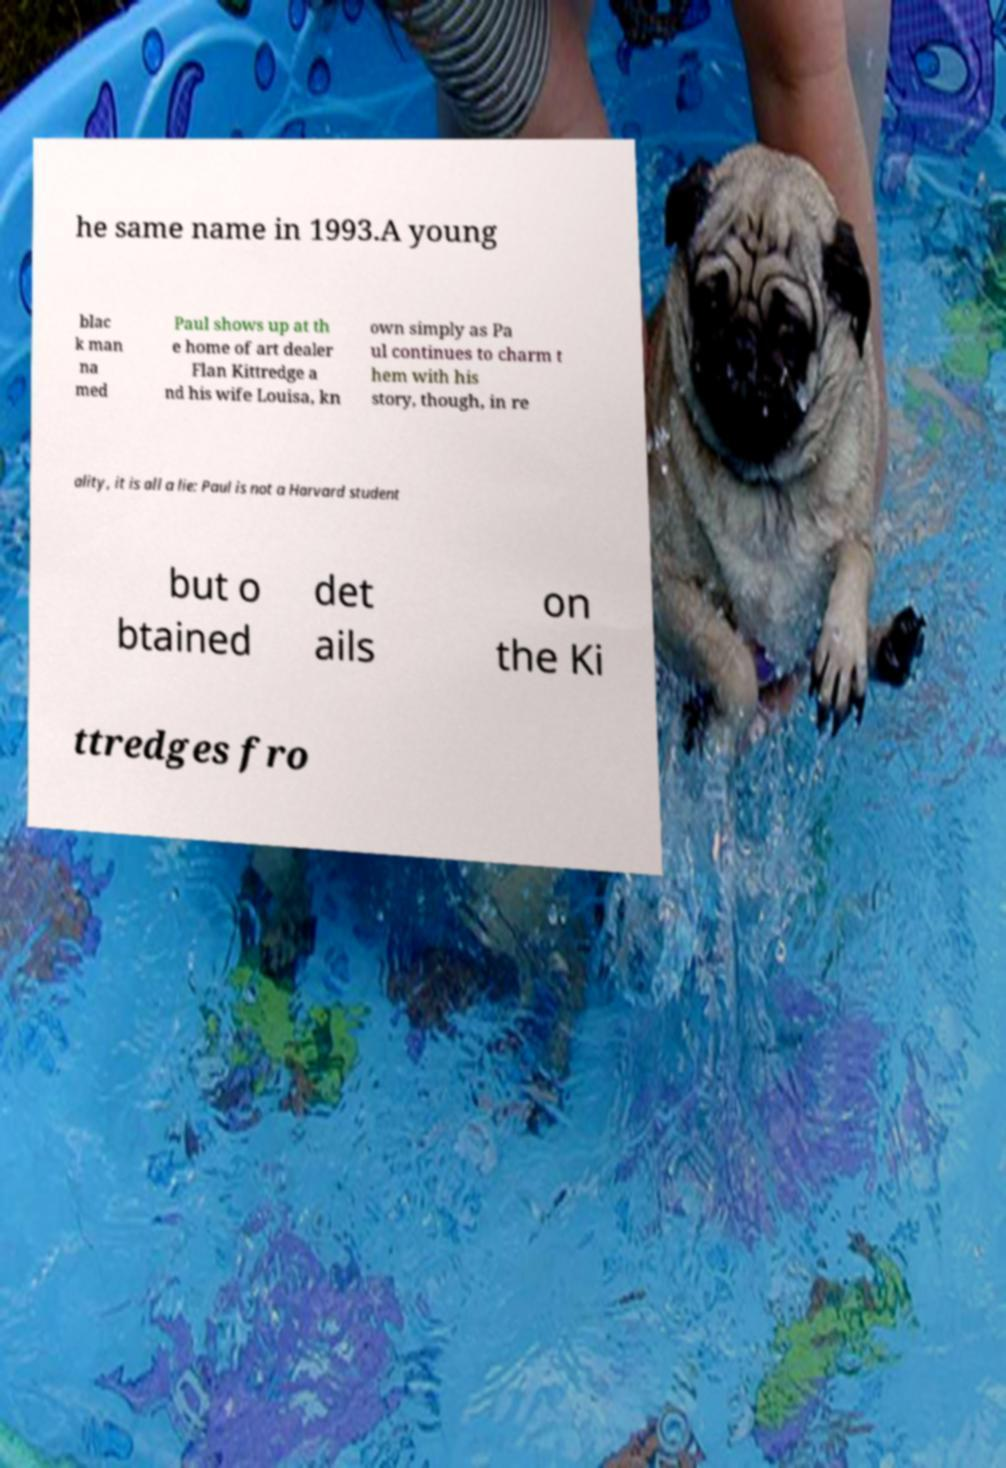Can you accurately transcribe the text from the provided image for me? he same name in 1993.A young blac k man na med Paul shows up at th e home of art dealer Flan Kittredge a nd his wife Louisa, kn own simply as Pa ul continues to charm t hem with his story, though, in re ality, it is all a lie: Paul is not a Harvard student but o btained det ails on the Ki ttredges fro 